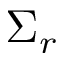Convert formula to latex. <formula><loc_0><loc_0><loc_500><loc_500>\Sigma _ { r }</formula> 